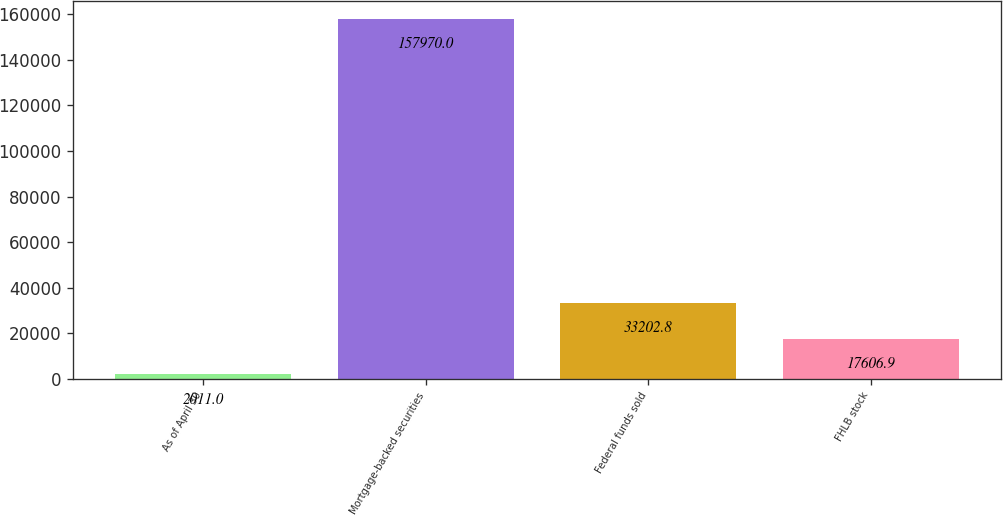<chart> <loc_0><loc_0><loc_500><loc_500><bar_chart><fcel>As of April 30<fcel>Mortgage-backed securities<fcel>Federal funds sold<fcel>FHLB stock<nl><fcel>2011<fcel>157970<fcel>33202.8<fcel>17606.9<nl></chart> 